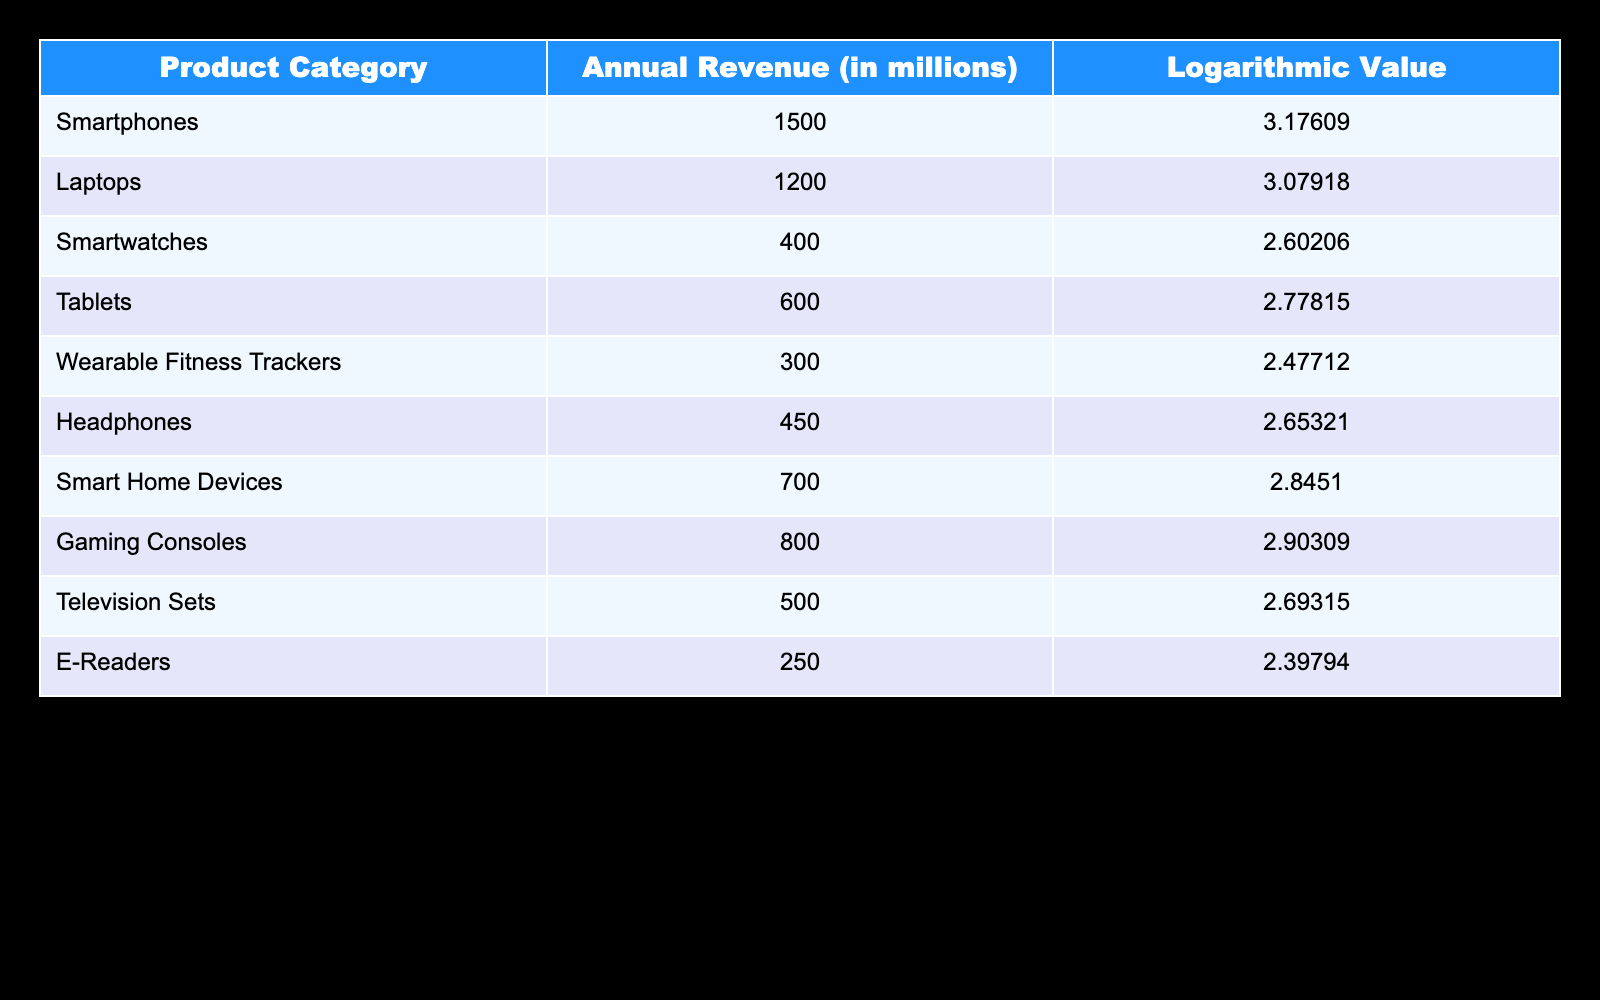What is the annual revenue generated by smartphones? The table shows that the annual revenue generated by smartphones is listed directly in the corresponding row under the "Annual Revenue (in millions)" column. Looking at the Smartphones row, the value is 1500 million.
Answer: 1500 million What is the logarithmic value for gaming consoles? By checking the table, the logarithmic value for gaming consoles can be found in the "Logarithmic Value" column, aligned with the corresponding row for gaming consoles. It is 2.90309.
Answer: 2.90309 Which product category has the lowest annual revenue? The lowest annual revenue can be determined by scanning the "Annual Revenue (in millions)" column and identifying the smallest value. Here, the lowest value is 250 million, corresponding to the E-Readers category.
Answer: E-Readers What is the total annual revenue of smart home devices and tablets combined? To find the total revenue, we first look at the annual revenues of both categories from the table: Smart Home Devices has 700 million and Tablets has 600 million. We then sum these values: 700 + 600 = 1300.
Answer: 1300 million Is the revenue from wearable fitness trackers greater than that from headphones? From the table, we see that the revenue from wearable fitness trackers is 300 million and from headphones is 450 million. By comparing these two values, we can see that 300 million is not greater than 450 million, so the answer is false.
Answer: No What is the average annual revenue of the top three product categories? The top three product categories by revenue are Smartphones (1500 million), Laptops (1200 million), and Gaming Consoles (800 million). To find the average, we add the revenues: 1500 + 1200 + 800 = 3500 million. Then, we divide this sum by the number of categories (3): 3500 / 3 = 1166.67 million.
Answer: 1166.67 million Which product categories have an annual revenue greater than 600 million? To solve this, we must review the "Annual Revenue (in millions)" column and filter out categories that exceed 600 million. These categories are Smartphones (1500 million), Laptops (1200 million), Smart Home Devices (700 million), and Gaming Consoles (800 million).
Answer: Smartphones, Laptops, Smart Home Devices, Gaming Consoles What is the difference in revenue between the highest and lowest product categories? The highest revenue is found in the Smartphones category with 1500 million, while the lowest is in E-Readers with 250 million. To find the difference, we subtract the lowest from the highest: 1500 - 250 = 1250 million.
Answer: 1250 million 